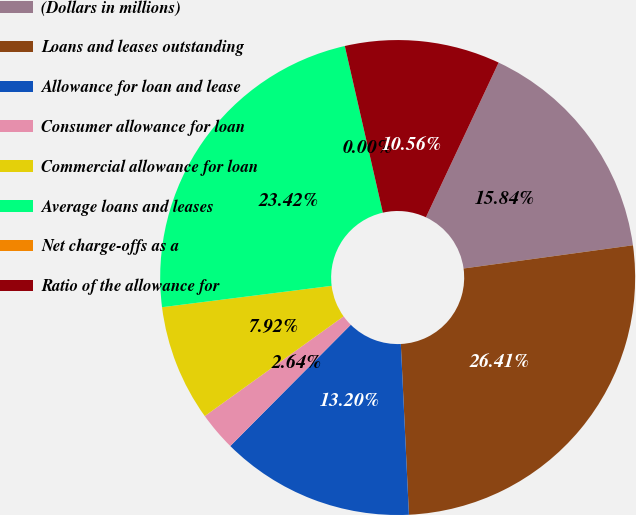Convert chart to OTSL. <chart><loc_0><loc_0><loc_500><loc_500><pie_chart><fcel>(Dollars in millions)<fcel>Loans and leases outstanding<fcel>Allowance for loan and lease<fcel>Consumer allowance for loan<fcel>Commercial allowance for loan<fcel>Average loans and leases<fcel>Net charge-offs as a<fcel>Ratio of the allowance for<nl><fcel>15.84%<fcel>26.41%<fcel>13.2%<fcel>2.64%<fcel>7.92%<fcel>23.42%<fcel>0.0%<fcel>10.56%<nl></chart> 